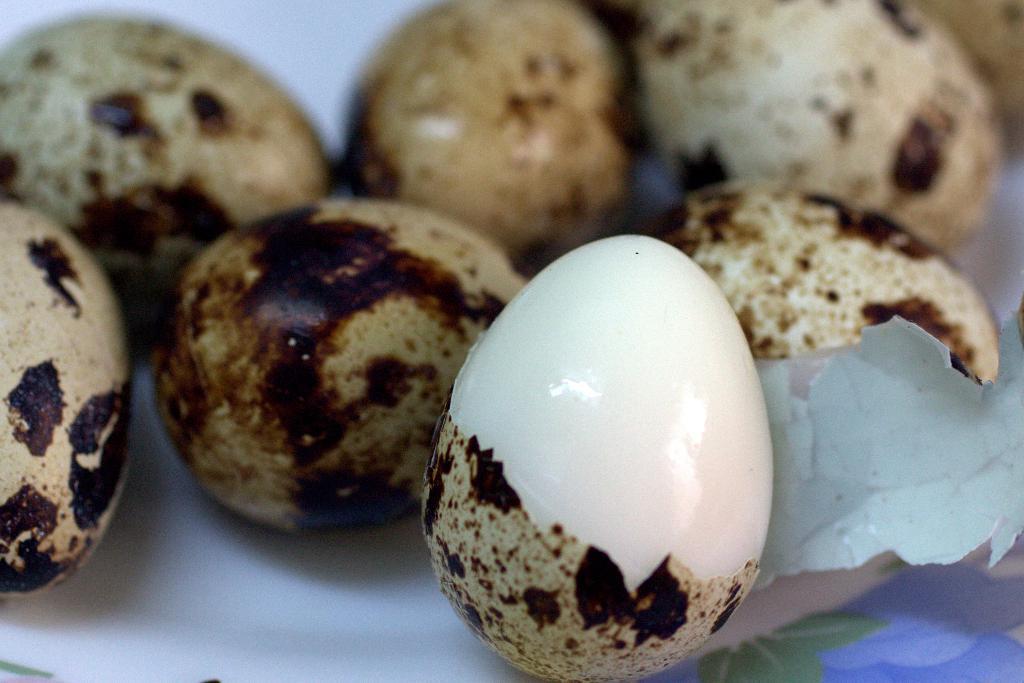Please provide a concise description of this image. In the image there are boiled eggs in a plate. 